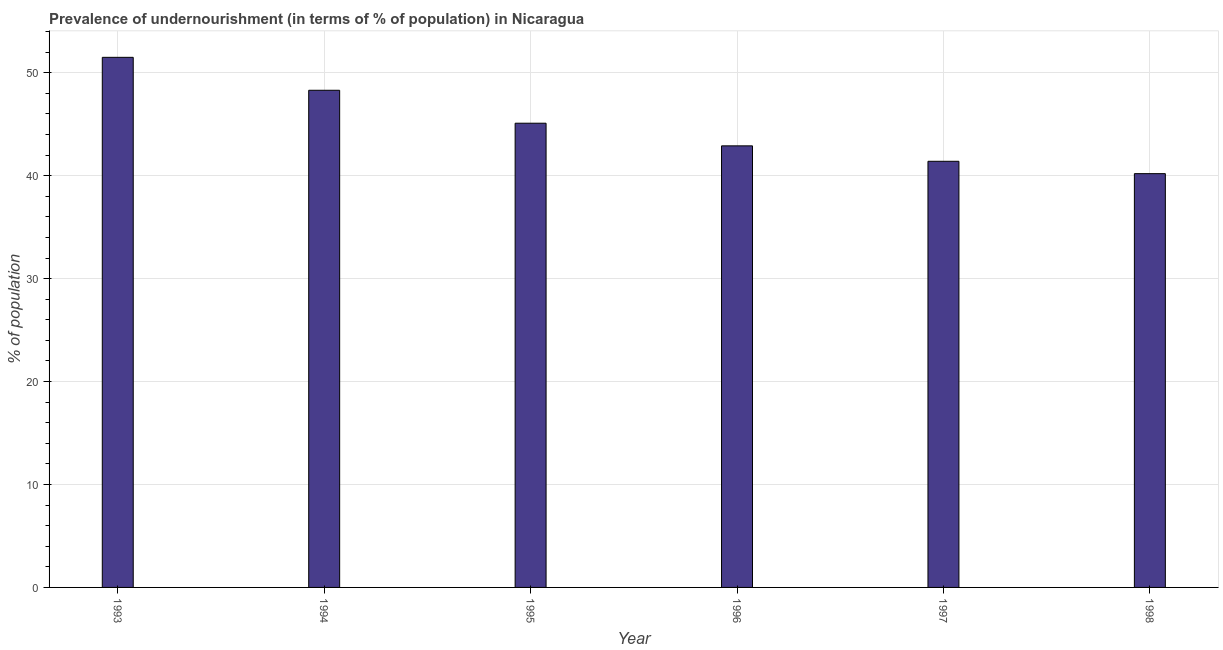Does the graph contain any zero values?
Keep it short and to the point. No. What is the title of the graph?
Provide a succinct answer. Prevalence of undernourishment (in terms of % of population) in Nicaragua. What is the label or title of the X-axis?
Provide a short and direct response. Year. What is the label or title of the Y-axis?
Provide a succinct answer. % of population. What is the percentage of undernourished population in 1993?
Ensure brevity in your answer.  51.5. Across all years, what is the maximum percentage of undernourished population?
Provide a succinct answer. 51.5. Across all years, what is the minimum percentage of undernourished population?
Give a very brief answer. 40.2. In which year was the percentage of undernourished population maximum?
Ensure brevity in your answer.  1993. In which year was the percentage of undernourished population minimum?
Your answer should be compact. 1998. What is the sum of the percentage of undernourished population?
Provide a short and direct response. 269.4. What is the difference between the percentage of undernourished population in 1995 and 1998?
Ensure brevity in your answer.  4.9. What is the average percentage of undernourished population per year?
Keep it short and to the point. 44.9. What is the median percentage of undernourished population?
Make the answer very short. 44. What is the ratio of the percentage of undernourished population in 1995 to that in 1998?
Offer a very short reply. 1.12. Is the percentage of undernourished population in 1995 less than that in 1996?
Offer a very short reply. No. What is the difference between the highest and the second highest percentage of undernourished population?
Your response must be concise. 3.2. Is the sum of the percentage of undernourished population in 1993 and 1997 greater than the maximum percentage of undernourished population across all years?
Your answer should be very brief. Yes. What is the difference between the highest and the lowest percentage of undernourished population?
Provide a succinct answer. 11.3. How many bars are there?
Ensure brevity in your answer.  6. Are all the bars in the graph horizontal?
Give a very brief answer. No. How many years are there in the graph?
Give a very brief answer. 6. What is the % of population of 1993?
Your answer should be compact. 51.5. What is the % of population in 1994?
Offer a very short reply. 48.3. What is the % of population of 1995?
Keep it short and to the point. 45.1. What is the % of population of 1996?
Offer a terse response. 42.9. What is the % of population in 1997?
Make the answer very short. 41.4. What is the % of population in 1998?
Your answer should be very brief. 40.2. What is the difference between the % of population in 1993 and 1994?
Ensure brevity in your answer.  3.2. What is the difference between the % of population in 1993 and 1995?
Your response must be concise. 6.4. What is the difference between the % of population in 1993 and 1996?
Offer a terse response. 8.6. What is the difference between the % of population in 1993 and 1997?
Offer a terse response. 10.1. What is the difference between the % of population in 1994 and 1995?
Your answer should be very brief. 3.2. What is the difference between the % of population in 1994 and 1997?
Your answer should be very brief. 6.9. What is the difference between the % of population in 1994 and 1998?
Provide a short and direct response. 8.1. What is the difference between the % of population in 1995 and 1998?
Provide a short and direct response. 4.9. What is the difference between the % of population in 1996 and 1997?
Provide a succinct answer. 1.5. What is the difference between the % of population in 1996 and 1998?
Your response must be concise. 2.7. What is the difference between the % of population in 1997 and 1998?
Ensure brevity in your answer.  1.2. What is the ratio of the % of population in 1993 to that in 1994?
Provide a short and direct response. 1.07. What is the ratio of the % of population in 1993 to that in 1995?
Ensure brevity in your answer.  1.14. What is the ratio of the % of population in 1993 to that in 1996?
Provide a short and direct response. 1.2. What is the ratio of the % of population in 1993 to that in 1997?
Provide a succinct answer. 1.24. What is the ratio of the % of population in 1993 to that in 1998?
Your answer should be compact. 1.28. What is the ratio of the % of population in 1994 to that in 1995?
Provide a short and direct response. 1.07. What is the ratio of the % of population in 1994 to that in 1996?
Keep it short and to the point. 1.13. What is the ratio of the % of population in 1994 to that in 1997?
Make the answer very short. 1.17. What is the ratio of the % of population in 1994 to that in 1998?
Offer a very short reply. 1.2. What is the ratio of the % of population in 1995 to that in 1996?
Ensure brevity in your answer.  1.05. What is the ratio of the % of population in 1995 to that in 1997?
Provide a succinct answer. 1.09. What is the ratio of the % of population in 1995 to that in 1998?
Your answer should be compact. 1.12. What is the ratio of the % of population in 1996 to that in 1997?
Your response must be concise. 1.04. What is the ratio of the % of population in 1996 to that in 1998?
Make the answer very short. 1.07. 